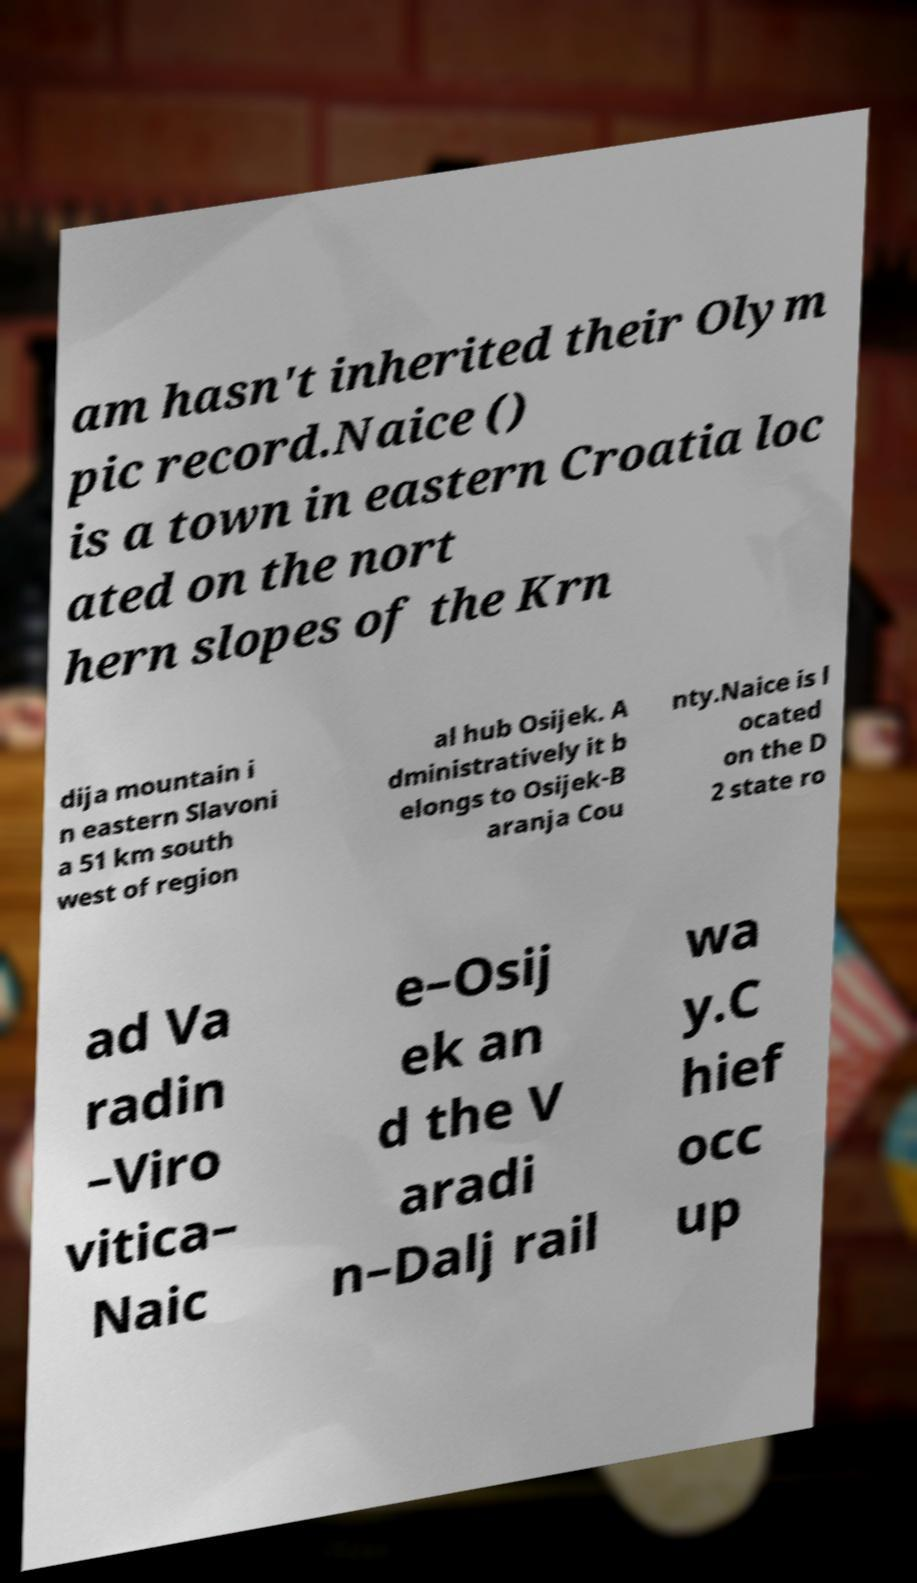Please identify and transcribe the text found in this image. am hasn't inherited their Olym pic record.Naice () is a town in eastern Croatia loc ated on the nort hern slopes of the Krn dija mountain i n eastern Slavoni a 51 km south west of region al hub Osijek. A dministratively it b elongs to Osijek-B aranja Cou nty.Naice is l ocated on the D 2 state ro ad Va radin –Viro vitica– Naic e–Osij ek an d the V aradi n–Dalj rail wa y.C hief occ up 